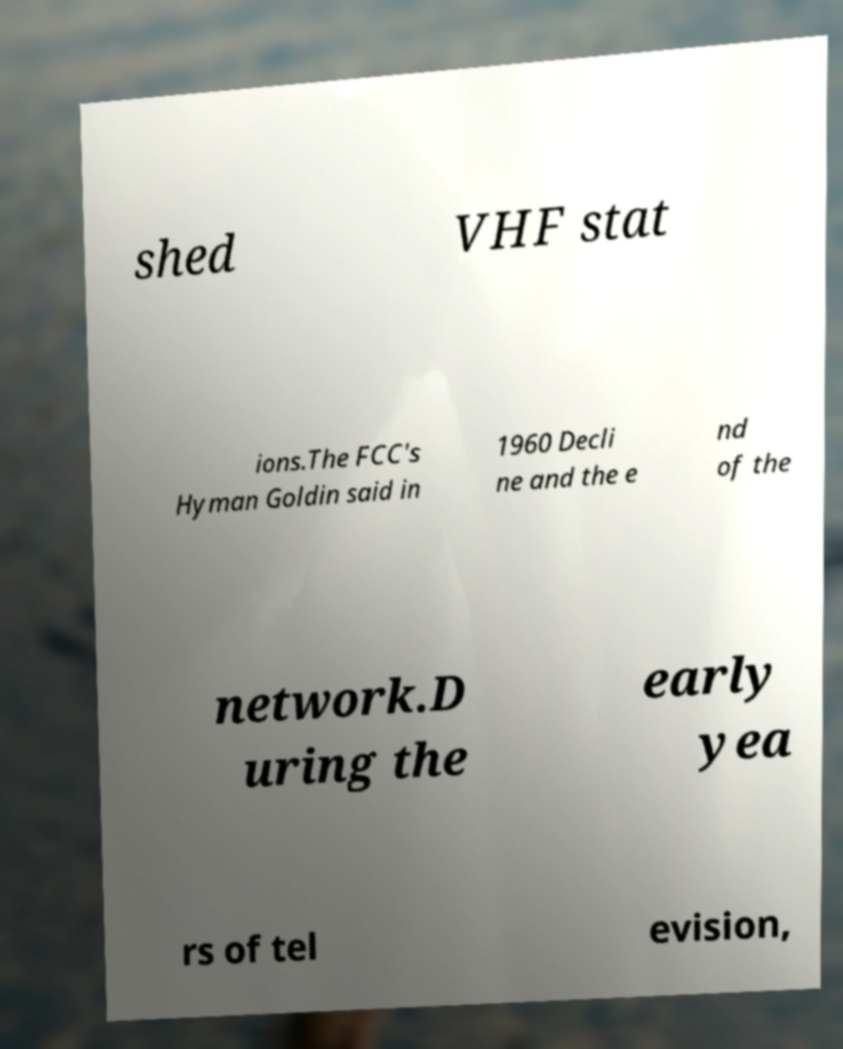Can you accurately transcribe the text from the provided image for me? shed VHF stat ions.The FCC's Hyman Goldin said in 1960 Decli ne and the e nd of the network.D uring the early yea rs of tel evision, 